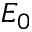<formula> <loc_0><loc_0><loc_500><loc_500>E _ { 0 }</formula> 